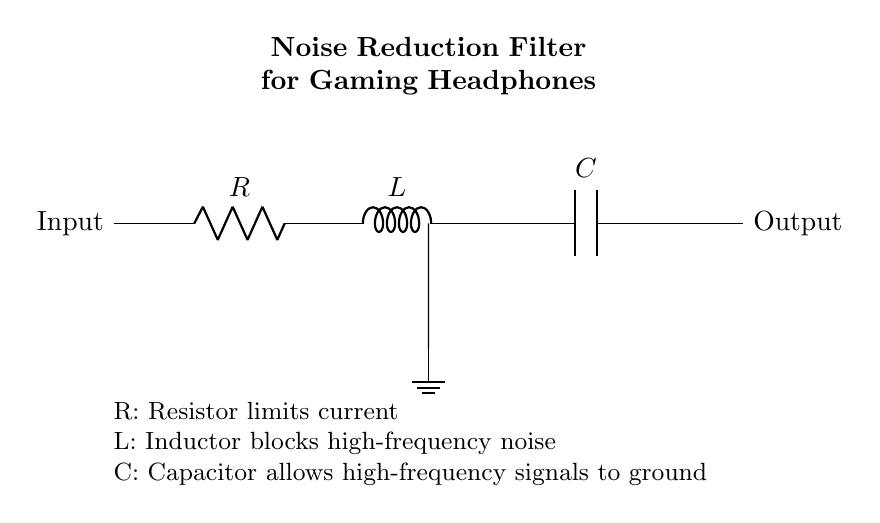What type of components are used in this noise reduction filter? The circuit consists of three types of components: a resistor, an inductor, and a capacitor. These are the key elements used for filtering noise in audio signals.
Answer: Resistor, Inductor, Capacitor What does the resistor do in this circuit? The resistor limits the current flowing through the circuit, thereby preventing potential damage to the other components and controlling the overall signal level.
Answer: Limits current What role does the inductor play in noise reduction? The inductor blocks high-frequency noise by presenting a high impedance to these frequencies, allowing lower frequency signals to pass more easily.
Answer: Blocks high-frequency noise How does the capacitor contribute to the functionality of this circuit? The capacitor shunts high-frequency signals to ground, effectively filtering them out of the output signal, which allows only the desired frequencies to pass through.
Answer: Allows high-frequency signals to ground What is the main purpose of the RLC circuit in gaming headphones? The main purpose is to reduce noise in audio signals, improving sound quality and reducing interference from unwanted frequencies while gaming.
Answer: Noise reduction 